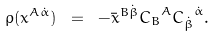<formula> <loc_0><loc_0><loc_500><loc_500>\rho ( x ^ { A \dot { \alpha } } ) \ = \ - \bar { x } ^ { B \dot { \beta } } { C _ { B } } ^ { A } { C _ { \dot { \beta } } } ^ { \dot { \alpha } } .</formula> 